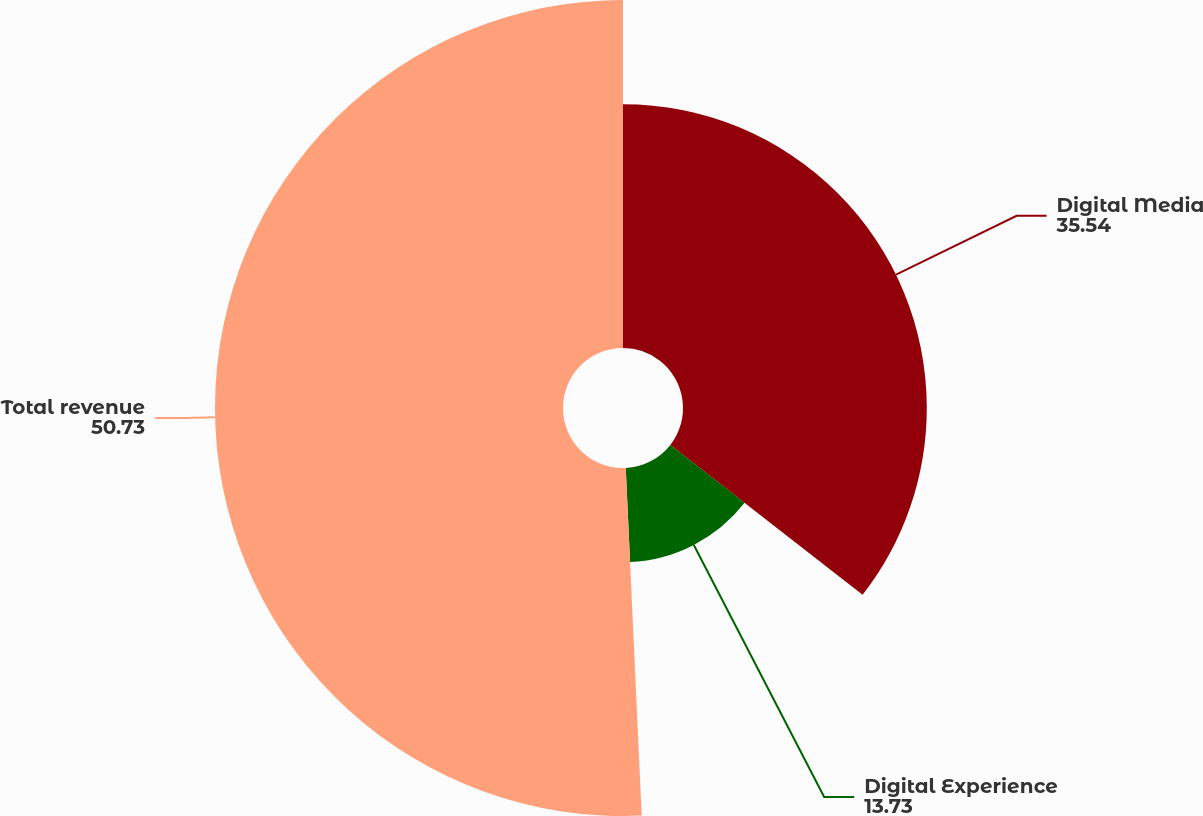<chart> <loc_0><loc_0><loc_500><loc_500><pie_chart><fcel>Digital Media<fcel>Digital Experience<fcel>Total revenue<nl><fcel>35.54%<fcel>13.73%<fcel>50.73%<nl></chart> 